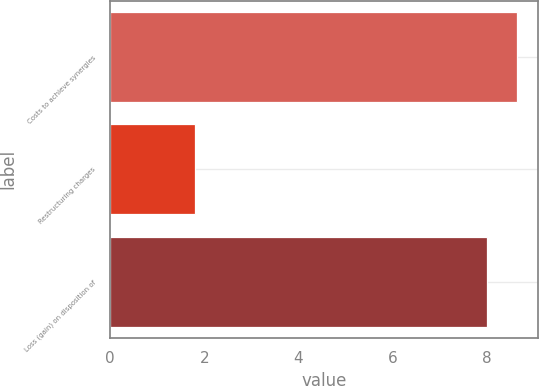Convert chart. <chart><loc_0><loc_0><loc_500><loc_500><bar_chart><fcel>Costs to achieve synergies<fcel>Restructuring charges<fcel>Loss (gain) on disposition of<nl><fcel>8.65<fcel>1.8<fcel>8<nl></chart> 